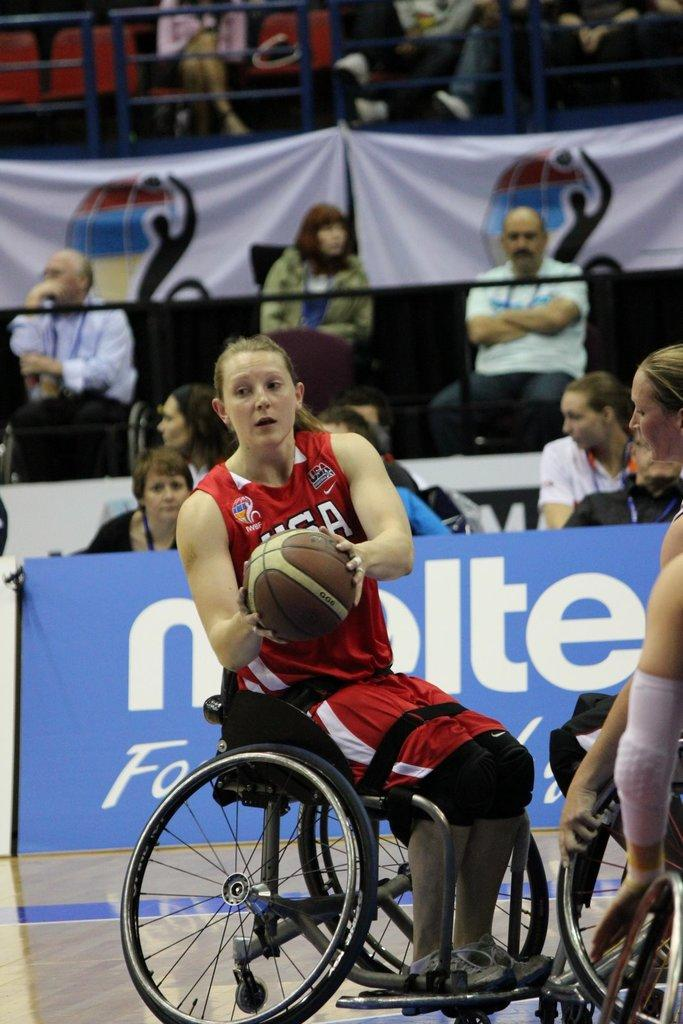What type of sport are the players in the image participating in? The players are playing basketball. What is the physical condition of the players in the image? The players are in wheelchairs, indicating that they may have mobility impairments. What can be seen in the background of the image? There is a banner with text and people sitting on chairs in the background of the image. Is there any quicksand visible in the image? No, there is no quicksand present in the image. What type of lace is used to decorate the basketball court in the image? There is no lace used to decorate the basketball court in the image; it is a regular basketball court. 